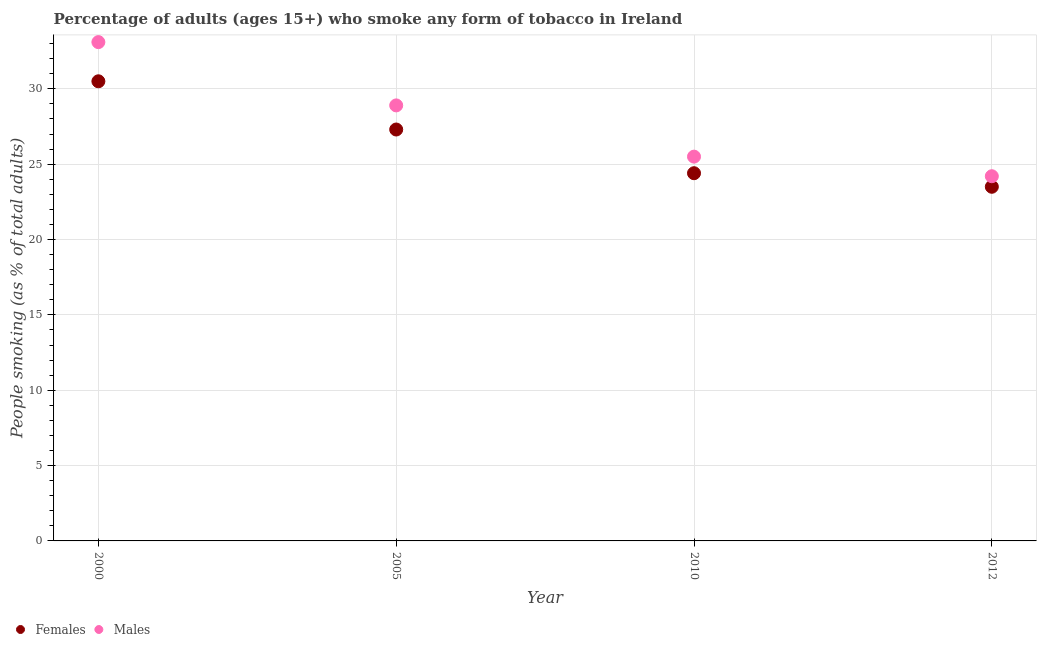How many different coloured dotlines are there?
Give a very brief answer. 2. What is the percentage of males who smoke in 2005?
Provide a short and direct response. 28.9. Across all years, what is the maximum percentage of males who smoke?
Give a very brief answer. 33.1. Across all years, what is the minimum percentage of males who smoke?
Your response must be concise. 24.2. In which year was the percentage of females who smoke maximum?
Your response must be concise. 2000. In which year was the percentage of males who smoke minimum?
Your response must be concise. 2012. What is the total percentage of males who smoke in the graph?
Provide a succinct answer. 111.7. What is the difference between the percentage of males who smoke in 2005 and that in 2012?
Make the answer very short. 4.7. What is the difference between the percentage of males who smoke in 2010 and the percentage of females who smoke in 2012?
Provide a short and direct response. 2. What is the average percentage of males who smoke per year?
Provide a short and direct response. 27.93. In the year 2012, what is the difference between the percentage of females who smoke and percentage of males who smoke?
Your response must be concise. -0.7. In how many years, is the percentage of females who smoke greater than 30 %?
Ensure brevity in your answer.  1. What is the ratio of the percentage of females who smoke in 2005 to that in 2010?
Your response must be concise. 1.12. What is the difference between the highest and the second highest percentage of males who smoke?
Your response must be concise. 4.2. What is the difference between the highest and the lowest percentage of males who smoke?
Give a very brief answer. 8.9. Does the percentage of females who smoke monotonically increase over the years?
Offer a very short reply. No. How many dotlines are there?
Offer a very short reply. 2. Does the graph contain any zero values?
Ensure brevity in your answer.  No. What is the title of the graph?
Make the answer very short. Percentage of adults (ages 15+) who smoke any form of tobacco in Ireland. Does "Rural Population" appear as one of the legend labels in the graph?
Offer a very short reply. No. What is the label or title of the X-axis?
Offer a very short reply. Year. What is the label or title of the Y-axis?
Give a very brief answer. People smoking (as % of total adults). What is the People smoking (as % of total adults) of Females in 2000?
Provide a short and direct response. 30.5. What is the People smoking (as % of total adults) of Males in 2000?
Your response must be concise. 33.1. What is the People smoking (as % of total adults) of Females in 2005?
Your response must be concise. 27.3. What is the People smoking (as % of total adults) in Males in 2005?
Your answer should be very brief. 28.9. What is the People smoking (as % of total adults) of Females in 2010?
Your response must be concise. 24.4. What is the People smoking (as % of total adults) of Males in 2010?
Ensure brevity in your answer.  25.5. What is the People smoking (as % of total adults) in Males in 2012?
Provide a succinct answer. 24.2. Across all years, what is the maximum People smoking (as % of total adults) of Females?
Provide a short and direct response. 30.5. Across all years, what is the maximum People smoking (as % of total adults) of Males?
Your response must be concise. 33.1. Across all years, what is the minimum People smoking (as % of total adults) in Males?
Offer a very short reply. 24.2. What is the total People smoking (as % of total adults) of Females in the graph?
Offer a terse response. 105.7. What is the total People smoking (as % of total adults) in Males in the graph?
Your answer should be compact. 111.7. What is the difference between the People smoking (as % of total adults) in Females in 2000 and that in 2010?
Ensure brevity in your answer.  6.1. What is the difference between the People smoking (as % of total adults) of Males in 2005 and that in 2010?
Your answer should be very brief. 3.4. What is the difference between the People smoking (as % of total adults) of Females in 2005 and that in 2012?
Offer a very short reply. 3.8. What is the difference between the People smoking (as % of total adults) of Females in 2010 and that in 2012?
Provide a succinct answer. 0.9. What is the difference between the People smoking (as % of total adults) in Males in 2010 and that in 2012?
Make the answer very short. 1.3. What is the difference between the People smoking (as % of total adults) of Females in 2000 and the People smoking (as % of total adults) of Males in 2010?
Provide a succinct answer. 5. What is the difference between the People smoking (as % of total adults) in Females in 2005 and the People smoking (as % of total adults) in Males in 2010?
Provide a short and direct response. 1.8. What is the difference between the People smoking (as % of total adults) of Females in 2010 and the People smoking (as % of total adults) of Males in 2012?
Your answer should be very brief. 0.2. What is the average People smoking (as % of total adults) of Females per year?
Ensure brevity in your answer.  26.43. What is the average People smoking (as % of total adults) in Males per year?
Provide a short and direct response. 27.93. In the year 2000, what is the difference between the People smoking (as % of total adults) of Females and People smoking (as % of total adults) of Males?
Offer a very short reply. -2.6. In the year 2010, what is the difference between the People smoking (as % of total adults) of Females and People smoking (as % of total adults) of Males?
Provide a succinct answer. -1.1. What is the ratio of the People smoking (as % of total adults) in Females in 2000 to that in 2005?
Provide a short and direct response. 1.12. What is the ratio of the People smoking (as % of total adults) of Males in 2000 to that in 2005?
Provide a succinct answer. 1.15. What is the ratio of the People smoking (as % of total adults) of Females in 2000 to that in 2010?
Offer a terse response. 1.25. What is the ratio of the People smoking (as % of total adults) in Males in 2000 to that in 2010?
Your answer should be very brief. 1.3. What is the ratio of the People smoking (as % of total adults) in Females in 2000 to that in 2012?
Provide a succinct answer. 1.3. What is the ratio of the People smoking (as % of total adults) of Males in 2000 to that in 2012?
Offer a very short reply. 1.37. What is the ratio of the People smoking (as % of total adults) in Females in 2005 to that in 2010?
Make the answer very short. 1.12. What is the ratio of the People smoking (as % of total adults) of Males in 2005 to that in 2010?
Provide a short and direct response. 1.13. What is the ratio of the People smoking (as % of total adults) of Females in 2005 to that in 2012?
Your answer should be compact. 1.16. What is the ratio of the People smoking (as % of total adults) in Males in 2005 to that in 2012?
Make the answer very short. 1.19. What is the ratio of the People smoking (as % of total adults) of Females in 2010 to that in 2012?
Ensure brevity in your answer.  1.04. What is the ratio of the People smoking (as % of total adults) in Males in 2010 to that in 2012?
Offer a terse response. 1.05. What is the difference between the highest and the second highest People smoking (as % of total adults) of Males?
Provide a succinct answer. 4.2. 